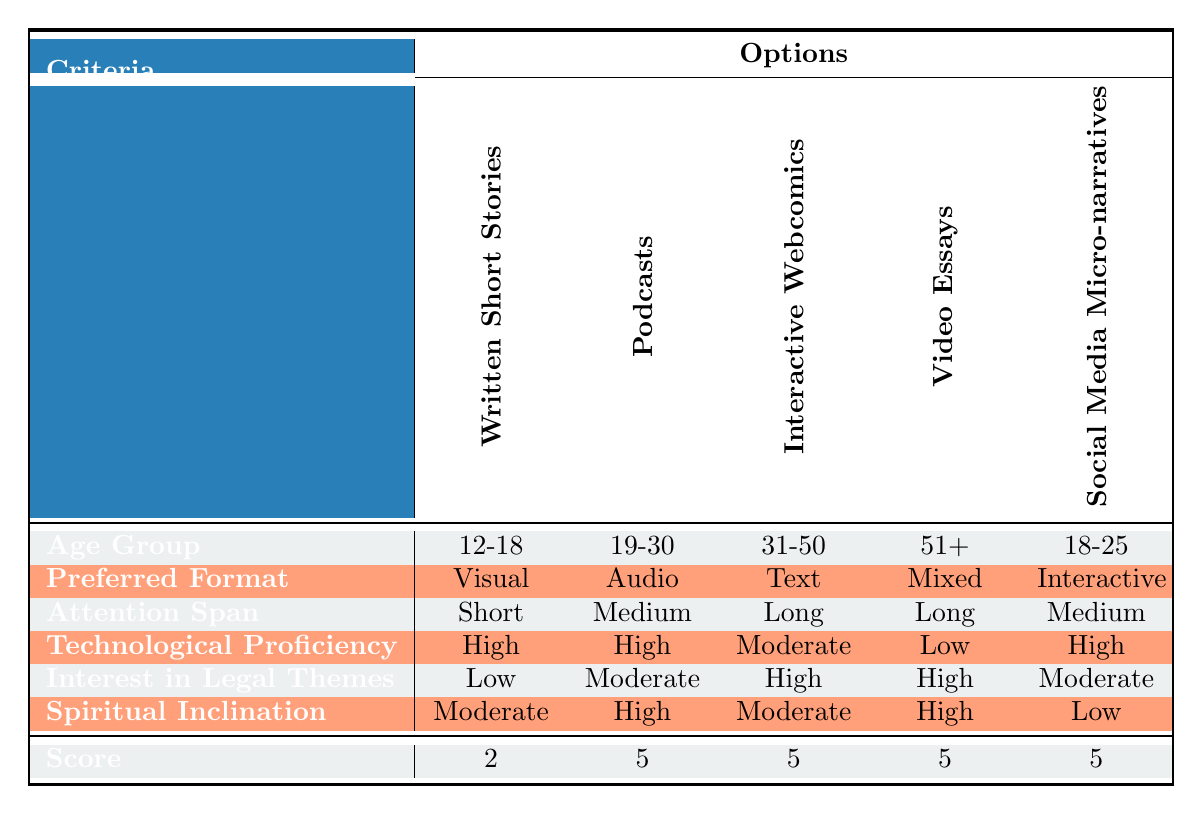What storytelling medium is preferred for the 12-18 age group? The table indicates that for the 12-18 age group, the score for Interactive Webcomics is the highest at 5. Thus, Interactive Webcomics is the preferred storytelling medium.
Answer: Interactive Webcomics Which medium scores the highest for the 31-50 age group? In the row for the 31-50 age group, the scores are listed as follows: Written Short Stories (5), Podcasts (3), Interactive Webcomics (1), Video Essays (4), Social Media Micro-narratives (2). The highest score is 5 for Written Short Stories.
Answer: Written Short Stories Is the interest in legal themes high for the 51+ age group? Referring to the 51+ age group, the Interest in Legal Themes is indicated as High. Therefore, the statement is true.
Answer: Yes What is the average score for Podcasts across all age groups? The scores for Podcasts are: 1 (12-18), 5 (19-30), 3 (31-50), 3 (51+), and 3 (18-25). To find the average, sum these scores: 1 + 5 + 3 + 3 + 3 = 15. Divide by the number of groups (5): 15 / 5 = 3.
Answer: 3 Which age group exhibits the lowest score for Social Media Micro-narratives? Checking the scores for Social Media Micro-narratives, they are: 3 (12-18), 1 (19-30), 2 (31-50), 2 (51+), and 1 (18-25). The lowest score is 1, which corresponds to the 19-30 and 18-25 age groups.
Answer: 19-30 and 18-25 How does technological proficiency align with age group preferences for interactive storytelling? The table shows that 12-18, 19-30, and 18-25 age groups have High technological proficiency and prefer Interactive Webcomics, while the 31-50 age group has Moderate proficiency and scores low for that medium (1). The 51+ age group, with Low proficiency, also scores low. This suggests younger audiences with higher proficiency align well with interactive storytelling.
Answer: Younger audiences prefer interactive storytelling Does a higher attention span correlate with better scores for any medium? Observing attention spans and scores reveals that higher attention spans (Long for 31-50 and 51+) correlate with relatively higher scores for Written Short Stories and Video Essays (both 4 or 5). Hence, a higher attention span does seem to correlate with better scores for these mediums.
Answer: Yes 